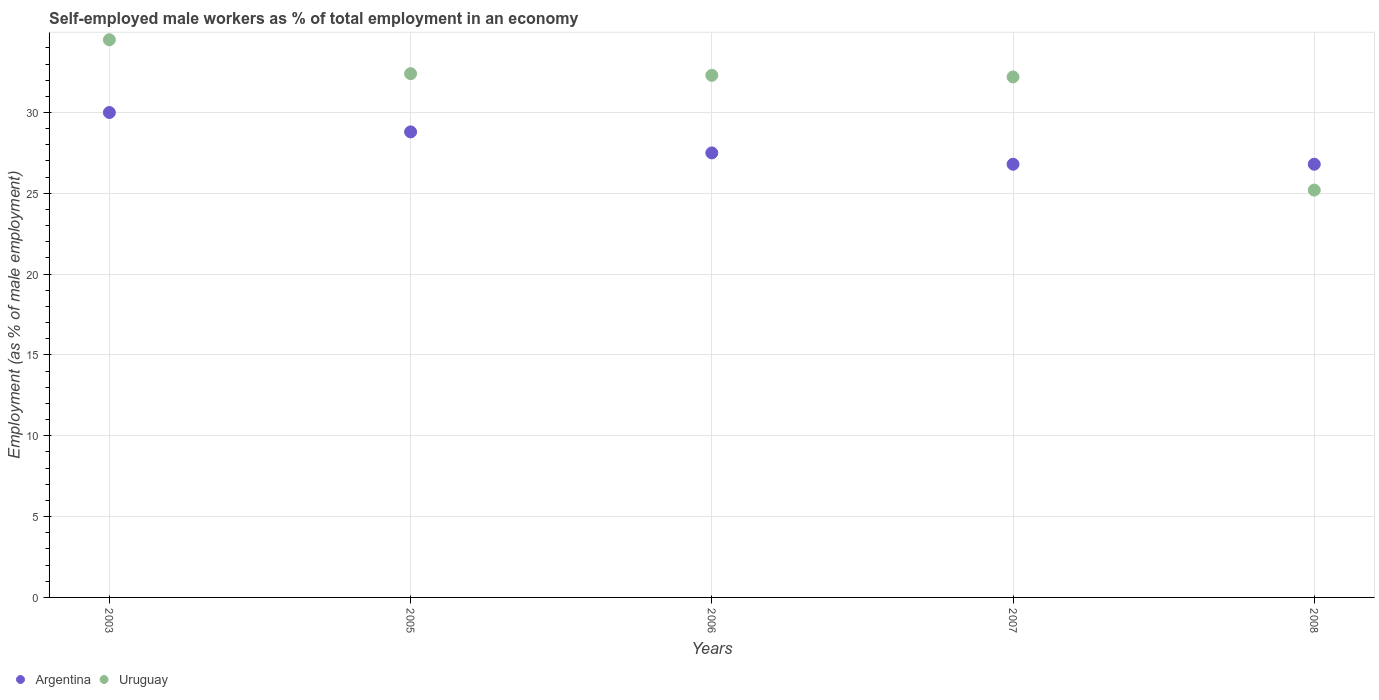What is the percentage of self-employed male workers in Uruguay in 2005?
Make the answer very short. 32.4. Across all years, what is the maximum percentage of self-employed male workers in Uruguay?
Give a very brief answer. 34.5. Across all years, what is the minimum percentage of self-employed male workers in Uruguay?
Offer a terse response. 25.2. What is the total percentage of self-employed male workers in Uruguay in the graph?
Your answer should be compact. 156.6. What is the difference between the percentage of self-employed male workers in Argentina in 2005 and that in 2008?
Your response must be concise. 2. What is the difference between the percentage of self-employed male workers in Uruguay in 2005 and the percentage of self-employed male workers in Argentina in 2008?
Keep it short and to the point. 5.6. What is the average percentage of self-employed male workers in Uruguay per year?
Provide a short and direct response. 31.32. In the year 2008, what is the difference between the percentage of self-employed male workers in Uruguay and percentage of self-employed male workers in Argentina?
Keep it short and to the point. -1.6. In how many years, is the percentage of self-employed male workers in Argentina greater than 7 %?
Ensure brevity in your answer.  5. What is the ratio of the percentage of self-employed male workers in Argentina in 2006 to that in 2007?
Your response must be concise. 1.03. Is the difference between the percentage of self-employed male workers in Uruguay in 2003 and 2008 greater than the difference between the percentage of self-employed male workers in Argentina in 2003 and 2008?
Make the answer very short. Yes. What is the difference between the highest and the second highest percentage of self-employed male workers in Argentina?
Provide a succinct answer. 1.2. What is the difference between the highest and the lowest percentage of self-employed male workers in Uruguay?
Your answer should be compact. 9.3. Is the sum of the percentage of self-employed male workers in Argentina in 2003 and 2006 greater than the maximum percentage of self-employed male workers in Uruguay across all years?
Provide a succinct answer. Yes. Is the percentage of self-employed male workers in Argentina strictly greater than the percentage of self-employed male workers in Uruguay over the years?
Provide a short and direct response. No. Is the percentage of self-employed male workers in Uruguay strictly less than the percentage of self-employed male workers in Argentina over the years?
Offer a terse response. No. How many dotlines are there?
Keep it short and to the point. 2. Does the graph contain grids?
Offer a very short reply. Yes. Where does the legend appear in the graph?
Ensure brevity in your answer.  Bottom left. How are the legend labels stacked?
Provide a succinct answer. Horizontal. What is the title of the graph?
Make the answer very short. Self-employed male workers as % of total employment in an economy. What is the label or title of the Y-axis?
Give a very brief answer. Employment (as % of male employment). What is the Employment (as % of male employment) in Argentina in 2003?
Ensure brevity in your answer.  30. What is the Employment (as % of male employment) in Uruguay in 2003?
Offer a very short reply. 34.5. What is the Employment (as % of male employment) in Argentina in 2005?
Ensure brevity in your answer.  28.8. What is the Employment (as % of male employment) of Uruguay in 2005?
Your answer should be compact. 32.4. What is the Employment (as % of male employment) of Argentina in 2006?
Your response must be concise. 27.5. What is the Employment (as % of male employment) of Uruguay in 2006?
Ensure brevity in your answer.  32.3. What is the Employment (as % of male employment) of Argentina in 2007?
Your answer should be compact. 26.8. What is the Employment (as % of male employment) in Uruguay in 2007?
Offer a terse response. 32.2. What is the Employment (as % of male employment) of Argentina in 2008?
Provide a short and direct response. 26.8. What is the Employment (as % of male employment) of Uruguay in 2008?
Your response must be concise. 25.2. Across all years, what is the maximum Employment (as % of male employment) in Argentina?
Provide a short and direct response. 30. Across all years, what is the maximum Employment (as % of male employment) of Uruguay?
Make the answer very short. 34.5. Across all years, what is the minimum Employment (as % of male employment) in Argentina?
Offer a very short reply. 26.8. Across all years, what is the minimum Employment (as % of male employment) in Uruguay?
Your answer should be compact. 25.2. What is the total Employment (as % of male employment) of Argentina in the graph?
Ensure brevity in your answer.  139.9. What is the total Employment (as % of male employment) of Uruguay in the graph?
Keep it short and to the point. 156.6. What is the difference between the Employment (as % of male employment) of Argentina in 2003 and that in 2005?
Give a very brief answer. 1.2. What is the difference between the Employment (as % of male employment) in Uruguay in 2003 and that in 2007?
Offer a very short reply. 2.3. What is the difference between the Employment (as % of male employment) in Argentina in 2003 and that in 2008?
Offer a very short reply. 3.2. What is the difference between the Employment (as % of male employment) of Uruguay in 2003 and that in 2008?
Offer a terse response. 9.3. What is the difference between the Employment (as % of male employment) in Uruguay in 2005 and that in 2006?
Offer a very short reply. 0.1. What is the difference between the Employment (as % of male employment) of Uruguay in 2005 and that in 2008?
Provide a succinct answer. 7.2. What is the difference between the Employment (as % of male employment) of Uruguay in 2006 and that in 2007?
Make the answer very short. 0.1. What is the difference between the Employment (as % of male employment) of Argentina in 2007 and that in 2008?
Your answer should be very brief. 0. What is the difference between the Employment (as % of male employment) in Uruguay in 2007 and that in 2008?
Ensure brevity in your answer.  7. What is the difference between the Employment (as % of male employment) in Argentina in 2005 and the Employment (as % of male employment) in Uruguay in 2006?
Make the answer very short. -3.5. What is the difference between the Employment (as % of male employment) in Argentina in 2006 and the Employment (as % of male employment) in Uruguay in 2007?
Ensure brevity in your answer.  -4.7. What is the average Employment (as % of male employment) in Argentina per year?
Your response must be concise. 27.98. What is the average Employment (as % of male employment) of Uruguay per year?
Offer a terse response. 31.32. In the year 2005, what is the difference between the Employment (as % of male employment) in Argentina and Employment (as % of male employment) in Uruguay?
Make the answer very short. -3.6. What is the ratio of the Employment (as % of male employment) in Argentina in 2003 to that in 2005?
Keep it short and to the point. 1.04. What is the ratio of the Employment (as % of male employment) in Uruguay in 2003 to that in 2005?
Offer a terse response. 1.06. What is the ratio of the Employment (as % of male employment) in Uruguay in 2003 to that in 2006?
Your answer should be compact. 1.07. What is the ratio of the Employment (as % of male employment) in Argentina in 2003 to that in 2007?
Your answer should be very brief. 1.12. What is the ratio of the Employment (as % of male employment) of Uruguay in 2003 to that in 2007?
Keep it short and to the point. 1.07. What is the ratio of the Employment (as % of male employment) in Argentina in 2003 to that in 2008?
Make the answer very short. 1.12. What is the ratio of the Employment (as % of male employment) of Uruguay in 2003 to that in 2008?
Provide a succinct answer. 1.37. What is the ratio of the Employment (as % of male employment) in Argentina in 2005 to that in 2006?
Your response must be concise. 1.05. What is the ratio of the Employment (as % of male employment) of Argentina in 2005 to that in 2007?
Provide a short and direct response. 1.07. What is the ratio of the Employment (as % of male employment) in Argentina in 2005 to that in 2008?
Keep it short and to the point. 1.07. What is the ratio of the Employment (as % of male employment) of Argentina in 2006 to that in 2007?
Provide a short and direct response. 1.03. What is the ratio of the Employment (as % of male employment) in Uruguay in 2006 to that in 2007?
Offer a very short reply. 1. What is the ratio of the Employment (as % of male employment) in Argentina in 2006 to that in 2008?
Provide a succinct answer. 1.03. What is the ratio of the Employment (as % of male employment) of Uruguay in 2006 to that in 2008?
Provide a short and direct response. 1.28. What is the ratio of the Employment (as % of male employment) of Uruguay in 2007 to that in 2008?
Offer a very short reply. 1.28. What is the difference between the highest and the second highest Employment (as % of male employment) of Argentina?
Ensure brevity in your answer.  1.2. What is the difference between the highest and the lowest Employment (as % of male employment) in Uruguay?
Give a very brief answer. 9.3. 